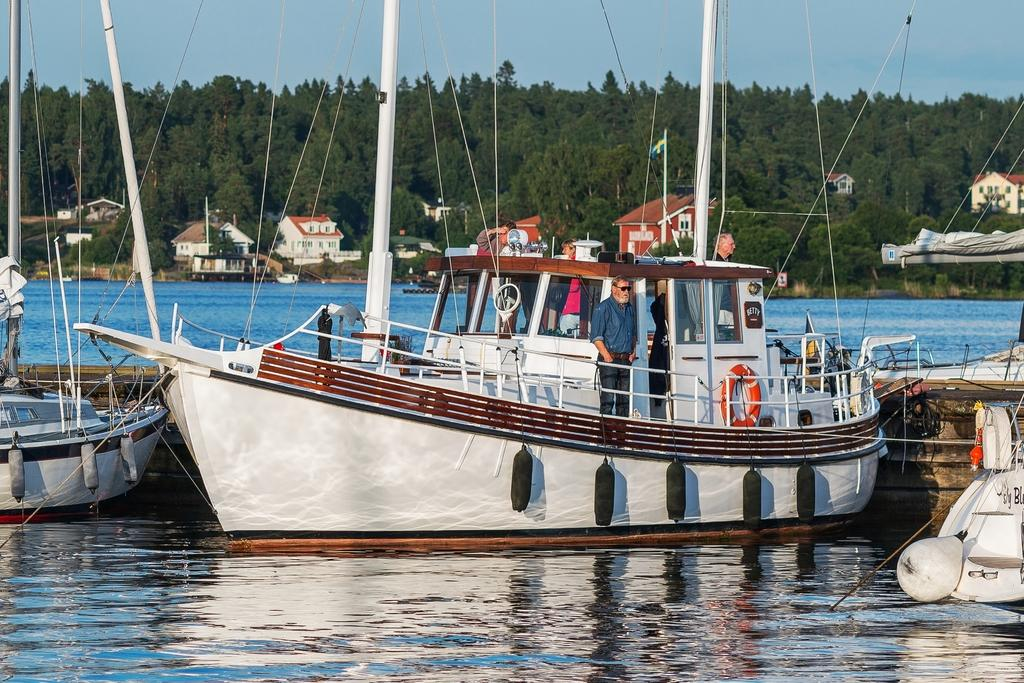What is the main subject of the image? The main subject of the image is people standing on a ship. What can be seen below the ship in the image? There is water visible at the bottom of the image. What type of natural environment is visible in the background of the image? There are trees and the sky visible in the background of the image. What type of stem can be seen growing from the ship in the image? There is no stem growing from the ship in the image. Can you describe the frog sitting on the edge of the ship in the image? There is no frog present in the image; it features people standing on a ship. 